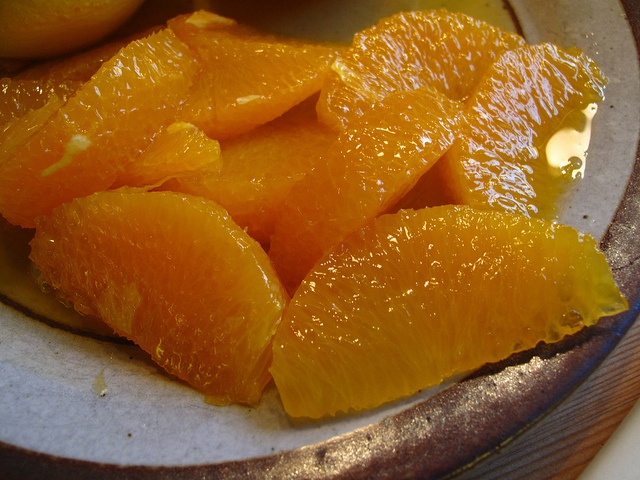Describe the objects in this image and their specific colors. I can see orange in maroon, red, and orange tones, orange in maroon, olive, and orange tones, orange in maroon and brown tones, orange in maroon, olive, tan, lightgray, and khaki tones, and orange in maroon, red, and orange tones in this image. 